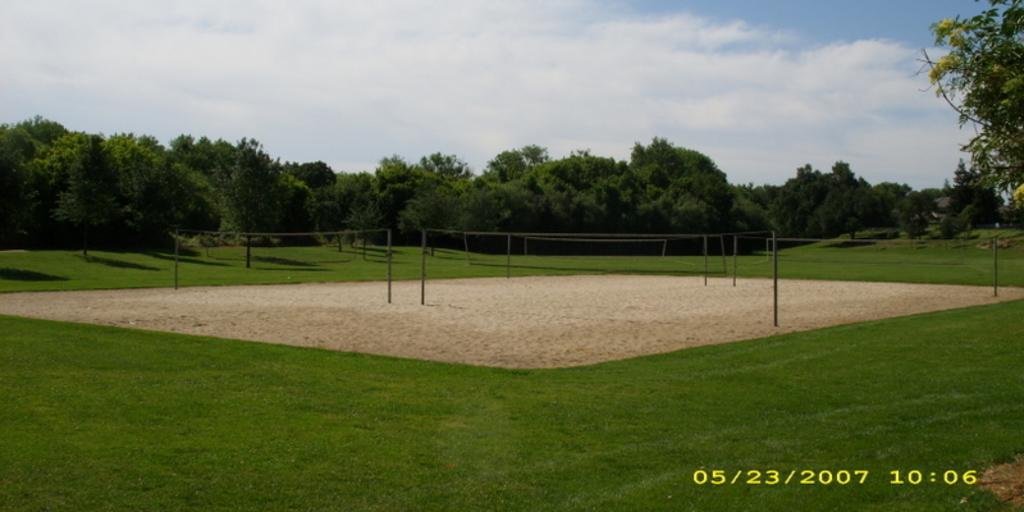Could you give a brief overview of what you see in this image? At the bottom of the image on the ground there is grass. In the middle of the ground there are poles. In the background there are trees. At the top of the image there is sky with clouds. 